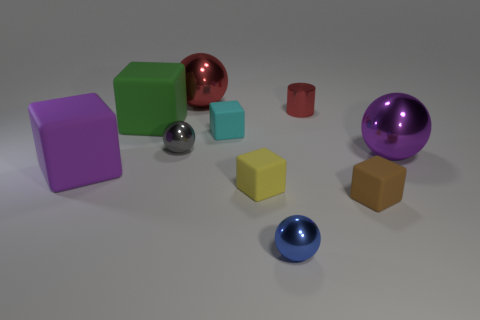There is a small cyan cube that is behind the small brown block; what number of brown objects are in front of it?
Offer a terse response. 1. How many big purple metallic things have the same shape as the small red shiny thing?
Make the answer very short. 0. How many small brown metallic spheres are there?
Keep it short and to the point. 0. The big object that is behind the green cube is what color?
Make the answer very short. Red. The large metallic sphere that is left of the big metal ball on the right side of the red shiny ball is what color?
Provide a short and direct response. Red. The other sphere that is the same size as the blue ball is what color?
Offer a terse response. Gray. What number of small objects are to the left of the small blue metal sphere and behind the big purple metal sphere?
Give a very brief answer. 2. What shape is the object that is the same color as the tiny cylinder?
Offer a very short reply. Sphere. What material is the cube that is both in front of the gray ball and on the left side of the yellow rubber block?
Ensure brevity in your answer.  Rubber. Are there fewer metallic spheres that are to the right of the tiny red object than large balls on the right side of the big purple matte thing?
Your response must be concise. Yes. 